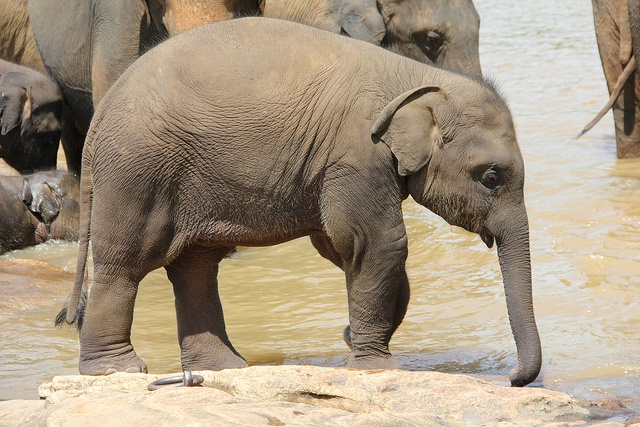Describe the objects in this image and their specific colors. I can see elephant in tan and gray tones, elephant in tan, gray, black, and darkgray tones, elephant in tan, darkgray, and gray tones, elephant in tan, gray, darkgray, and black tones, and elephant in tan, black, gray, and darkgray tones in this image. 